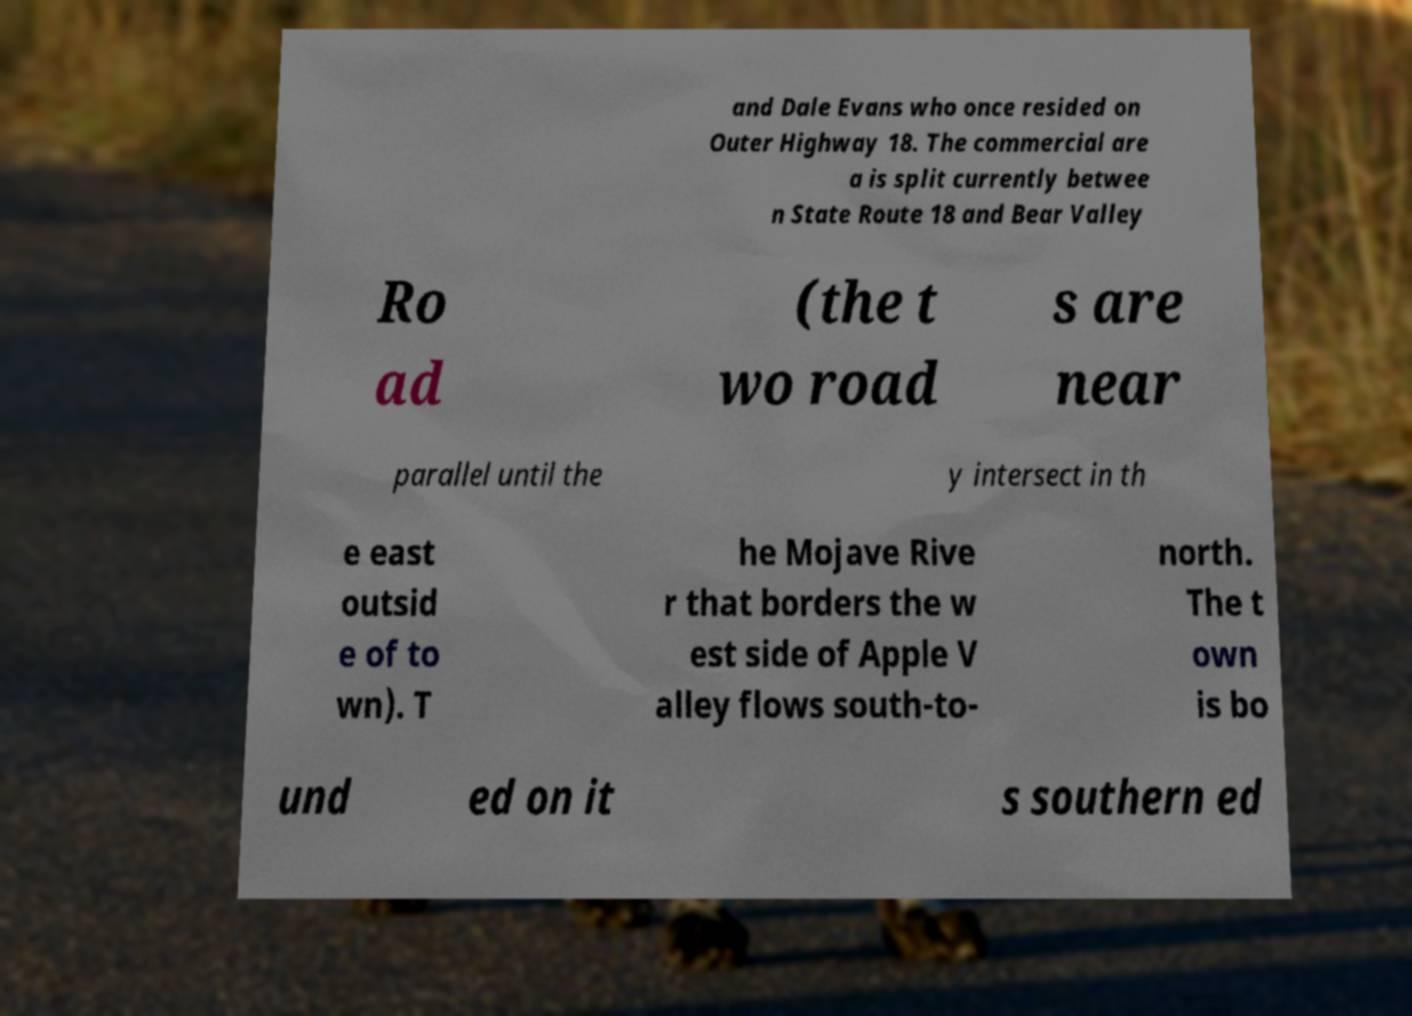Could you assist in decoding the text presented in this image and type it out clearly? and Dale Evans who once resided on Outer Highway 18. The commercial are a is split currently betwee n State Route 18 and Bear Valley Ro ad (the t wo road s are near parallel until the y intersect in th e east outsid e of to wn). T he Mojave Rive r that borders the w est side of Apple V alley flows south-to- north. The t own is bo und ed on it s southern ed 